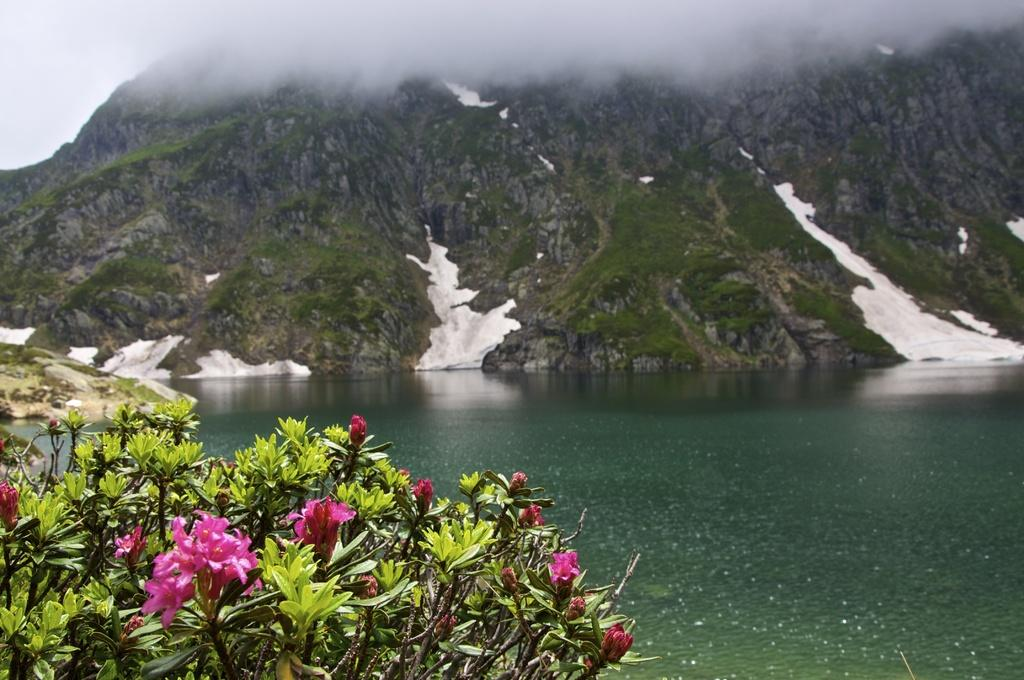What type of living organisms are present in the image? The image contains plants. What specific feature can be observed on the plants? The plants have flowers. What is visible at the bottom of the image? There is water at the bottom of the image. What type of landscape feature is visible in the background of the image? There is a mountain in the background of the image. What atmospheric condition is present in the background of the image? There is fog in the background of the image. Can you see any dolls interacting with the plants in the image? There are no dolls present in the image. Are there any dinosaurs visible in the image? There are no dinosaurs present in the image. 